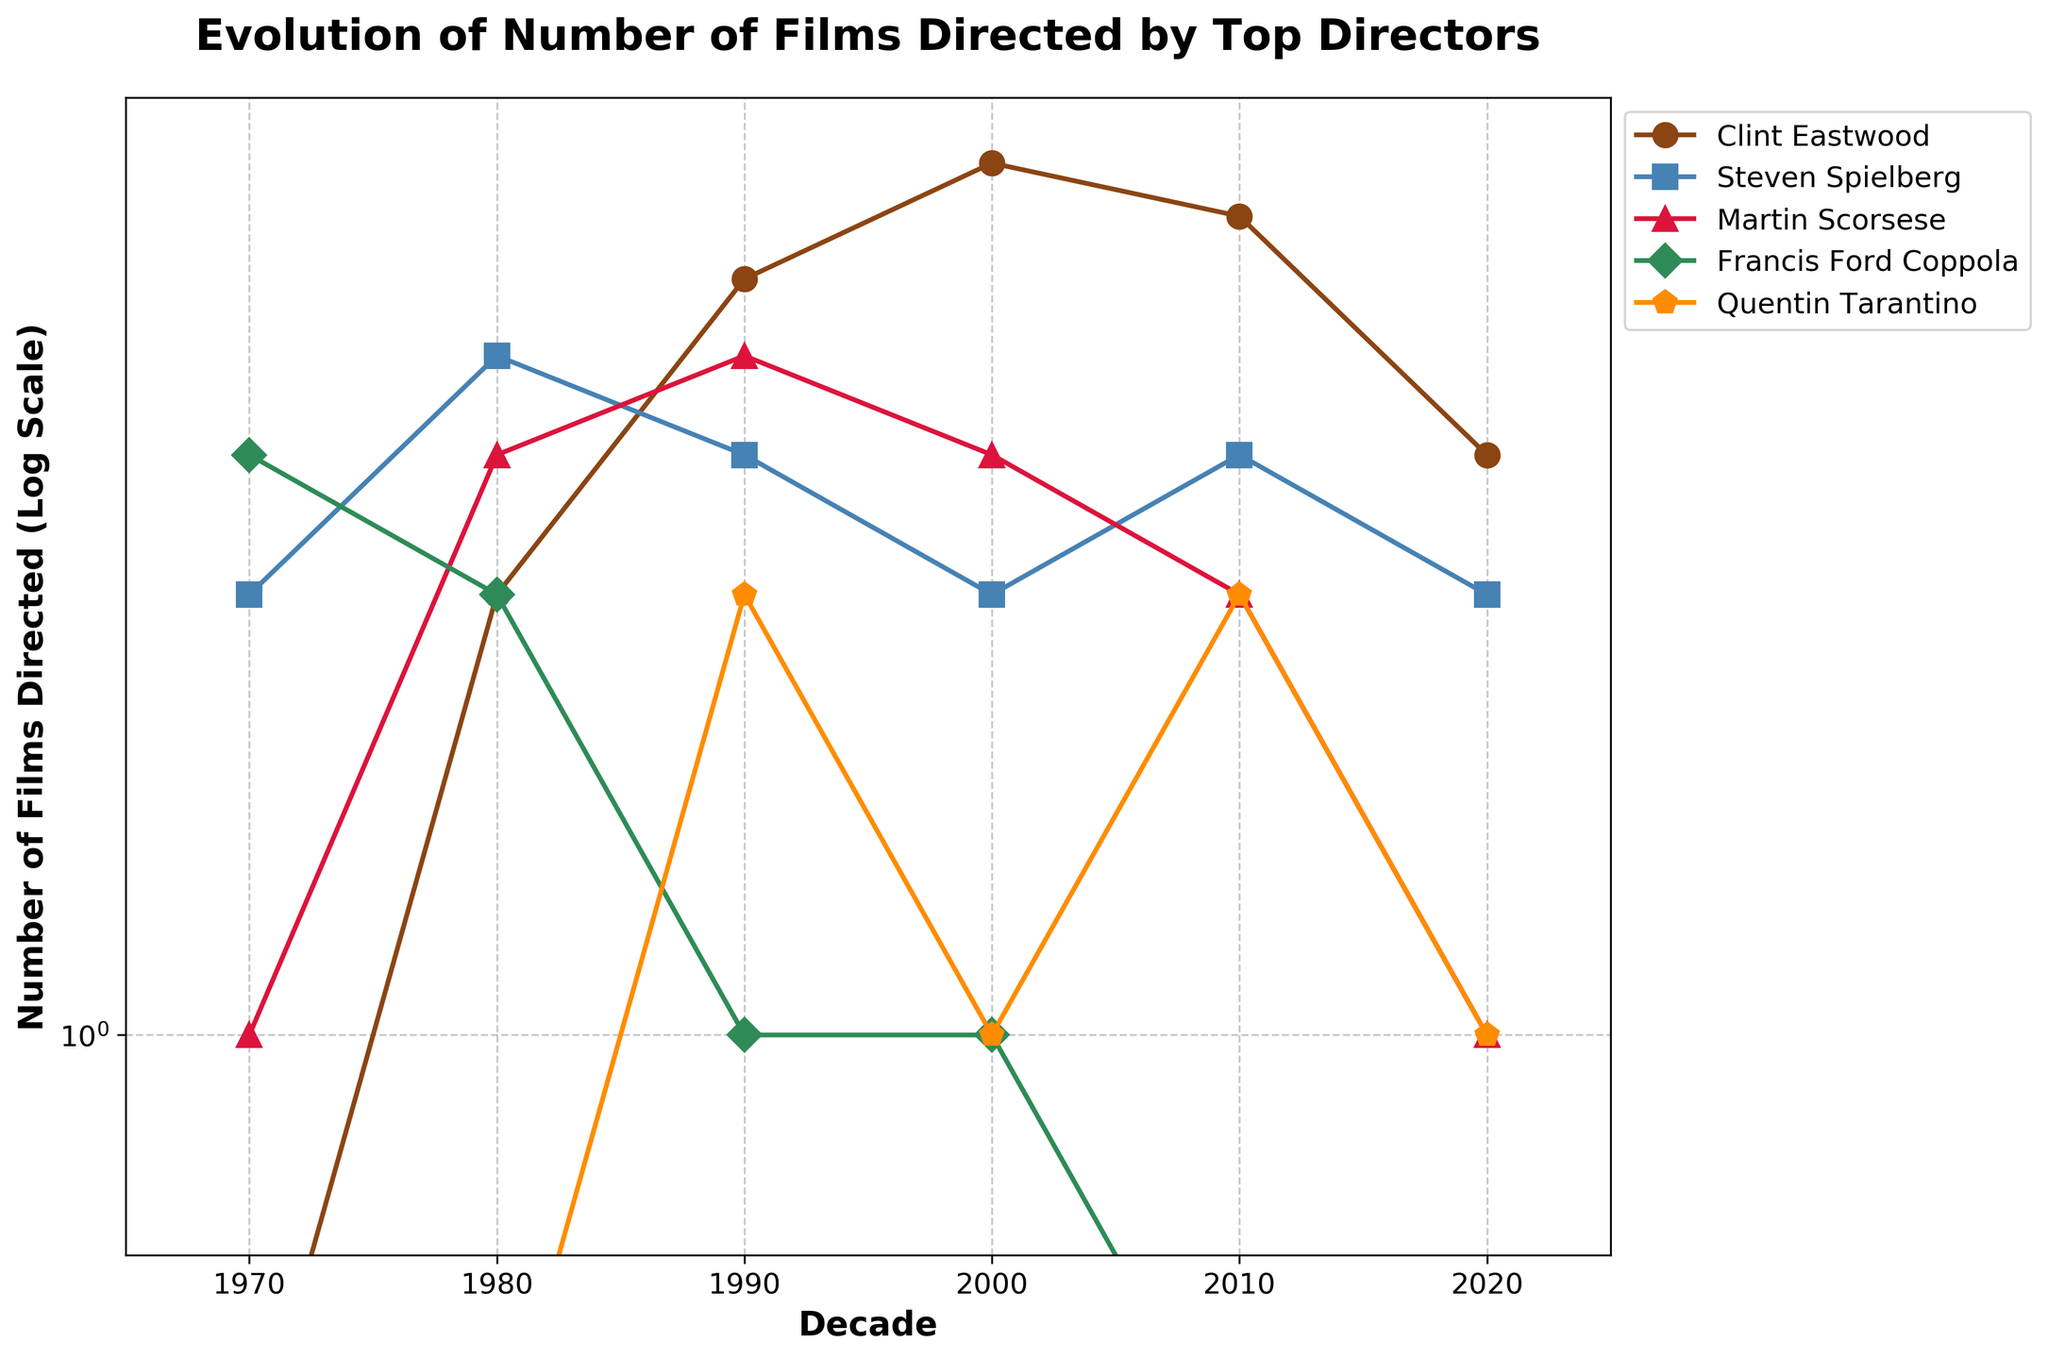What's the title of the plot? The title provides the main context for the plot, summarizing what the visual data represents. The title is located at the top of the plot.
Answer: Evolution of Number of Films Directed by Top Directors What are the decades represented on the x-axis? The x-axis represents different time periods, which are crucial for understanding the evolution over time.
Answer: 1970, 1980, 1990, 2000, 2010, 2020 How many total films did Clint Eastwood direct from 1970 to 2020? Sum up the number of films Clint Eastwood directed in each decade: 0 (1970s) + 2 (1980s) + 5 (1990s) + 7 (2000s) + 6 (2010s) + 3 (2020s).
Answer: 23 Which director directed the most films in any single decade? Identify the highest value across all directors and all decades in the plot and mention the corresponding director and decade.
Answer: Clint Eastwood in the 2000s (7 films) How did the number of films directed by Steven Spielberg change from the 1970s to the 2010s? Track the number of films Steven Spielberg directed in each decade from the 1970s to the 2010s: 2 (1970s) to 3 (2010s). Note the trend in values for a detailed explanation.
Answer: Increased by 1 film Which two directors had the same number of films directed in the 2010s? Look at the number of films each director directed in the 2010s and identify any equal values.
Answer: Quentin Tarantino and Martin Scorsese (2 films each) Compare the trends of Francis Ford Coppola and Quentin Tarantino from 1970 to 2020. Analyze the data points for both directors through the decades to identify trends, observing increases, decreases, or consistencies.
Answer: Coppola's trend decreases to 0 by 2000, Tarantino's trend starts at 0 and stays low with two peaks Between Martin Scorsese and Steven Spielberg, who had more films directed in the 1990s? Compare the data points for both directors in the 1990s.
Answer: Martin Scorsese (4 films) had more than Steven Spielberg (3 films) By how much did the number of films directed by Clint Eastwood decrease from the 2000s to the 2020s? Find the difference between the number of films directed by Clint Eastwood in the 2000s (7 films) and the 2020s (3 films).
Answer: Decreased by 4 films 